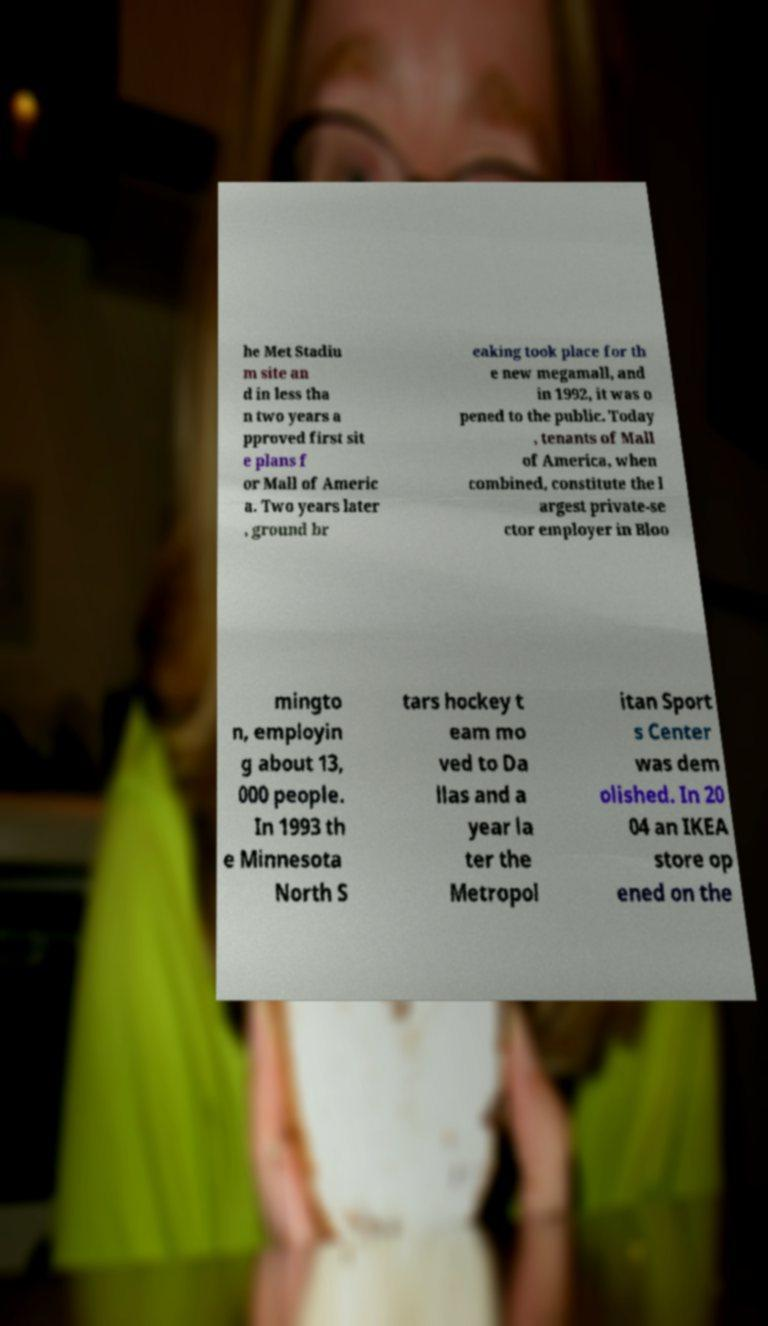For documentation purposes, I need the text within this image transcribed. Could you provide that? he Met Stadiu m site an d in less tha n two years a pproved first sit e plans f or Mall of Americ a. Two years later , ground br eaking took place for th e new megamall, and in 1992, it was o pened to the public. Today , tenants of Mall of America, when combined, constitute the l argest private-se ctor employer in Bloo mingto n, employin g about 13, 000 people. In 1993 th e Minnesota North S tars hockey t eam mo ved to Da llas and a year la ter the Metropol itan Sport s Center was dem olished. In 20 04 an IKEA store op ened on the 